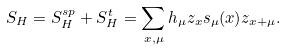<formula> <loc_0><loc_0><loc_500><loc_500>S _ { H } = S _ { H } ^ { s p } + S _ { H } ^ { t } = \sum _ { x , \mu } h _ { \mu } z _ { x } s _ { \mu } ( x ) z _ { x + \mu } .</formula> 